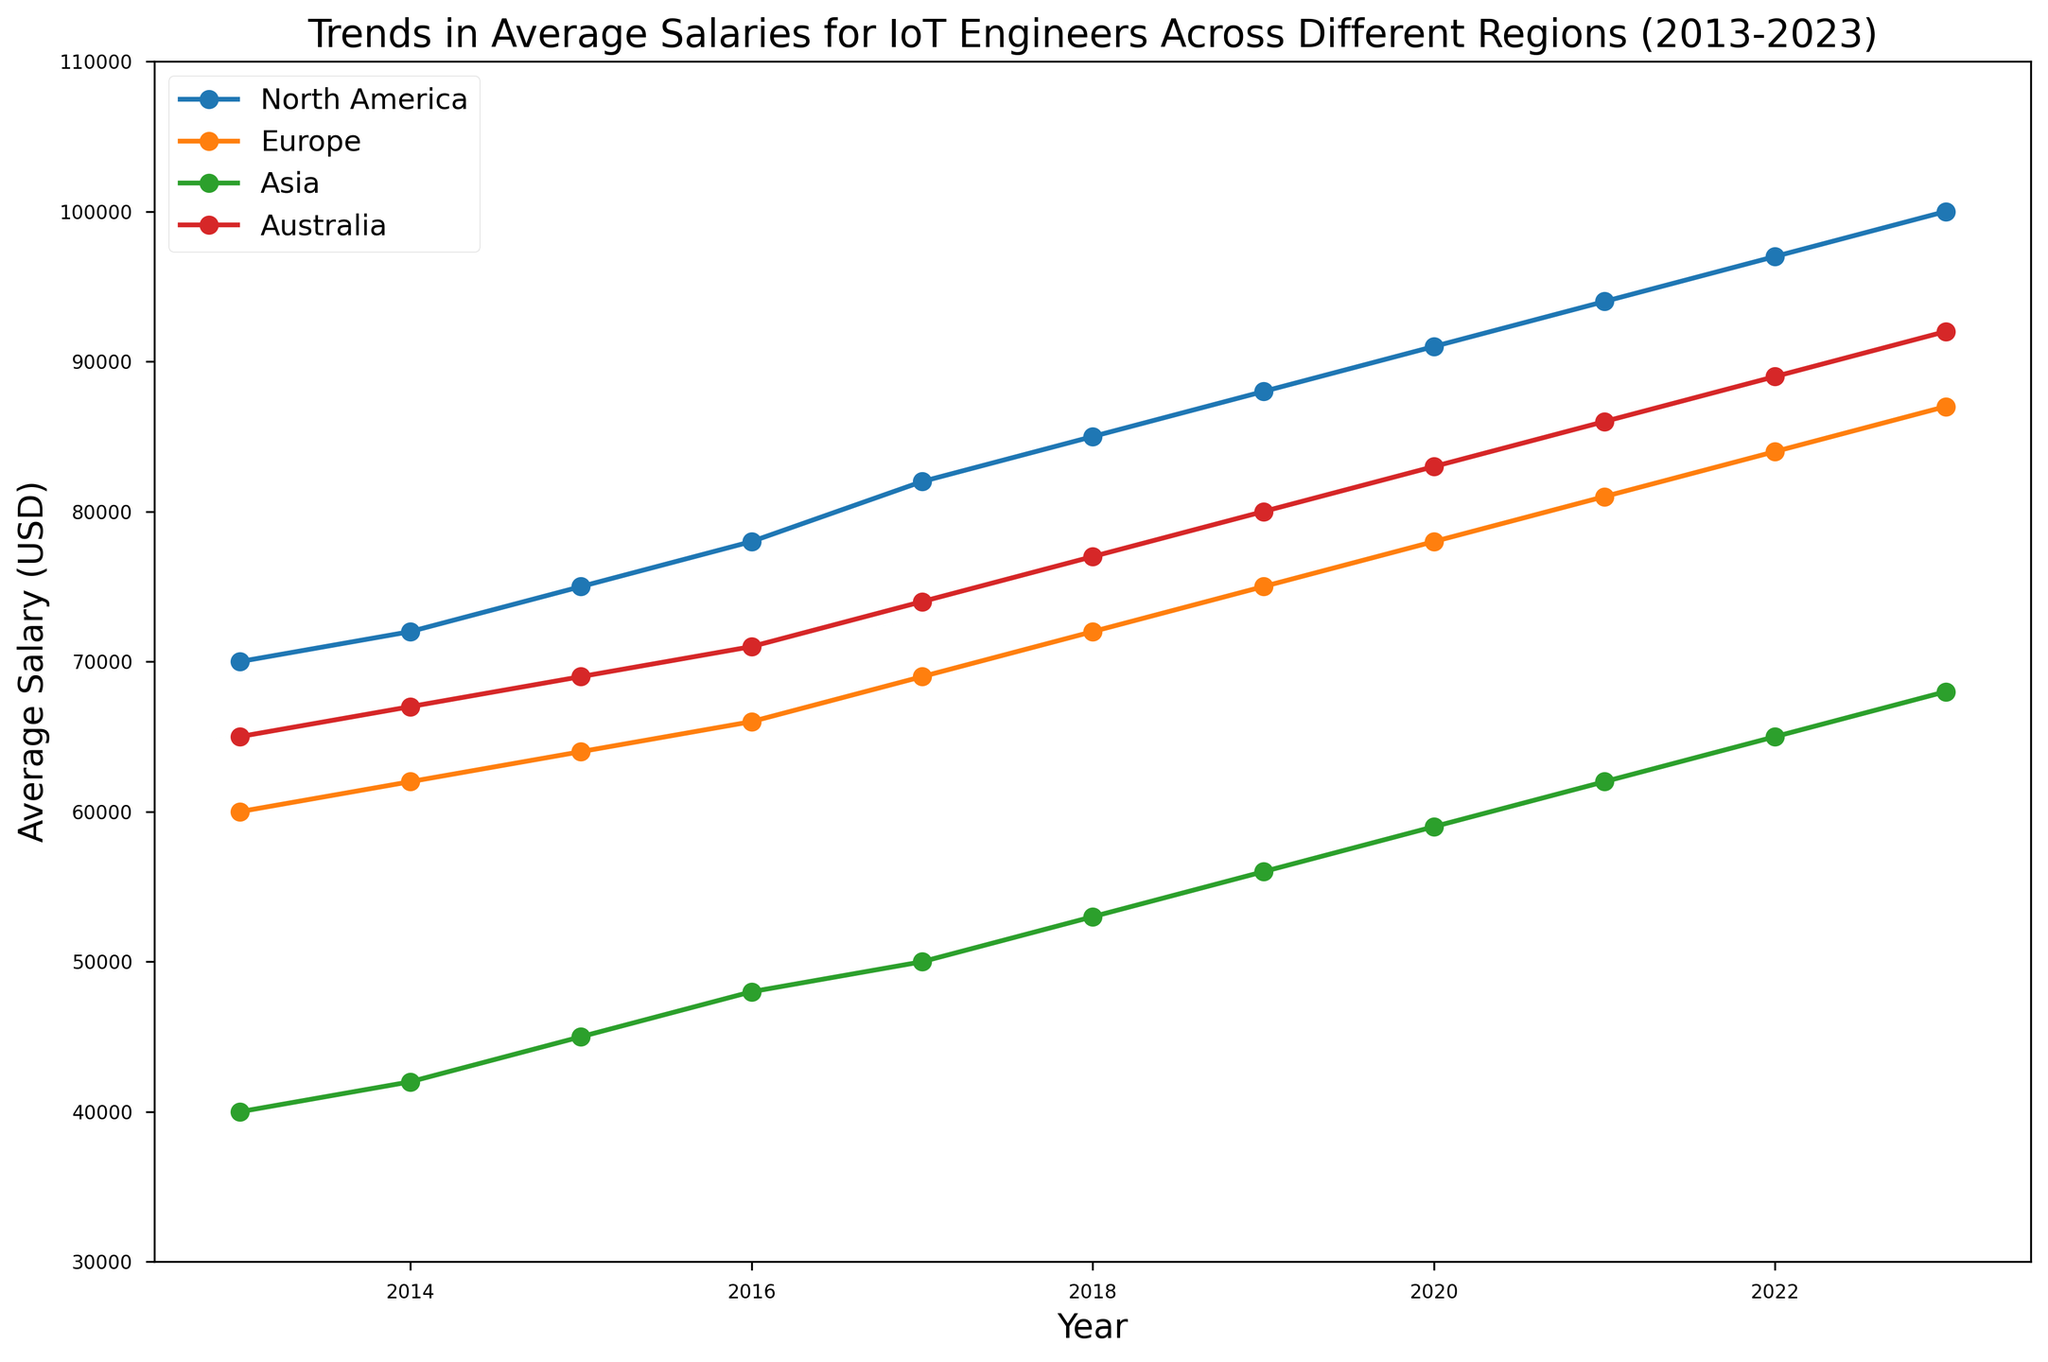What's the trend observed in average salaries for IoT Engineers in North America over the last 10 years? The plot shows a consistent upward trend in average salaries for IoT Engineers in North America from $70,000 in 2013 to $100,000 in 2023.
Answer: Upward trend Which region had the highest average salary for IoT Engineers in 2023? In the plot for the year 2023, the line representing North America reaches the highest value, which is $100,000.
Answer: North America How much did the average salary for IoT Engineers increase in Europe from 2013 to 2023? The salary in Europe increased from $60,000 in 2013 to $87,000 in 2023. The difference is $87,000 - $60,000 = $27,000.
Answer: $27,000 Which region shows the steepest increase in average salaries between 2013 and 2023? By comparing the slopes of the lines for each region over the years, North America shows the steepest increase from $70,000 to $100,000.
Answer: North America What is the approximate average salary for IoT Engineers in Asia over the given period? Averaging the given salaries: (40000 + 42000 + 45000 + 48000 + 50000 + 53000 + 56000 + 59000 + 62000 + 65000 + 68000) / 11 = 52454.55.
Answer: $52,455 Compare the salary trends in Australia and Europe. Which region had higher growth? In 2013, Australia started at $65,000 and Europe at $60,000. By 2023, Australia reached $92,000 and Europe $87,000. Australia's growth is $27,000, while Europe's is $27,000. Both regions had equal growth.
Answer: Equal growth In which year did the average salary for IoT Engineers in North America surpass $90,000? The plot shows that in 2020, the average salary for North America was $91,000 which is the first year surpassing $90,000.
Answer: 2020 What is the difference in the average salary for IoT Engineers between Asia and North America in 2019? In 2019, the salary in Asia was $56,000 and in North America it was $88,000. The difference is $88,000 - $56,000 = $32,000.
Answer: $32,000 Did the average salary for IoT Engineers in Australia ever surpass the average salary in Europe? Throughout the period from 2013 to 2023, the plot shows that Australia's average salary was always higher than that of Europe.
Answer: Yes 